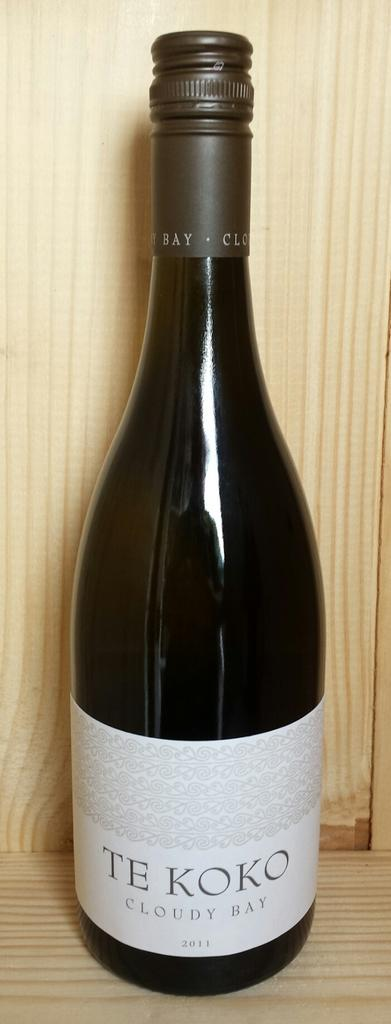<image>
Describe the image concisely. A bottle of TE KOKO CLOUDY BAY 2011 is pictured. 